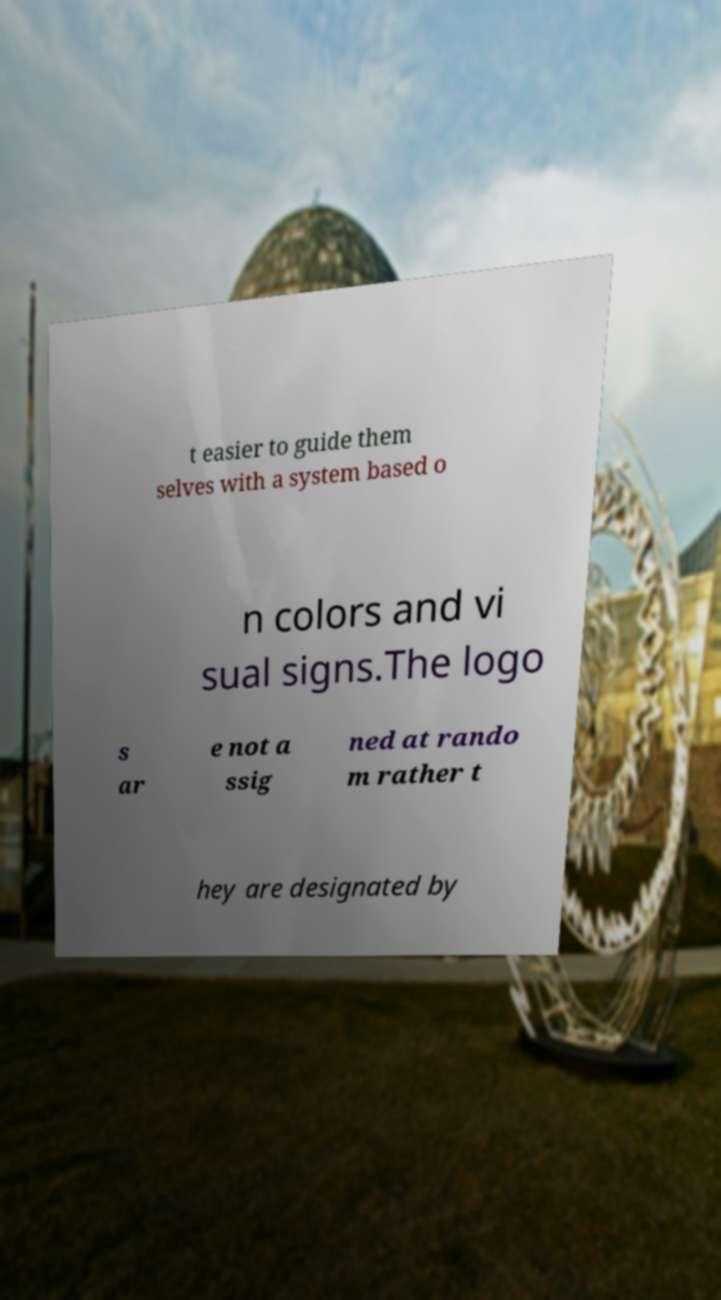Can you accurately transcribe the text from the provided image for me? t easier to guide them selves with a system based o n colors and vi sual signs.The logo s ar e not a ssig ned at rando m rather t hey are designated by 